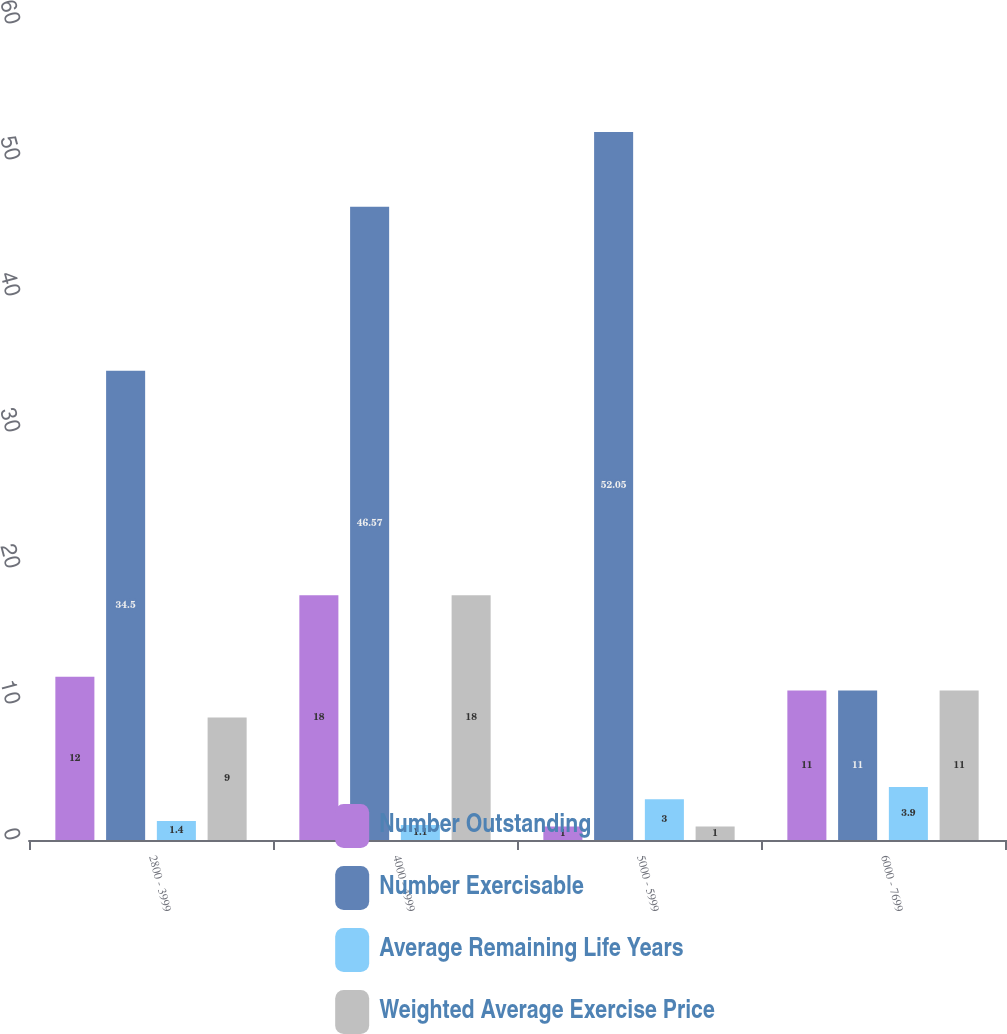Convert chart. <chart><loc_0><loc_0><loc_500><loc_500><stacked_bar_chart><ecel><fcel>2800 - 3999<fcel>4000 - 4999<fcel>5000 - 5999<fcel>6000 - 7699<nl><fcel>Number Outstanding<fcel>12<fcel>18<fcel>1<fcel>11<nl><fcel>Number Exercisable<fcel>34.5<fcel>46.57<fcel>52.05<fcel>11<nl><fcel>Average Remaining Life Years<fcel>1.4<fcel>1.1<fcel>3<fcel>3.9<nl><fcel>Weighted Average Exercise Price<fcel>9<fcel>18<fcel>1<fcel>11<nl></chart> 